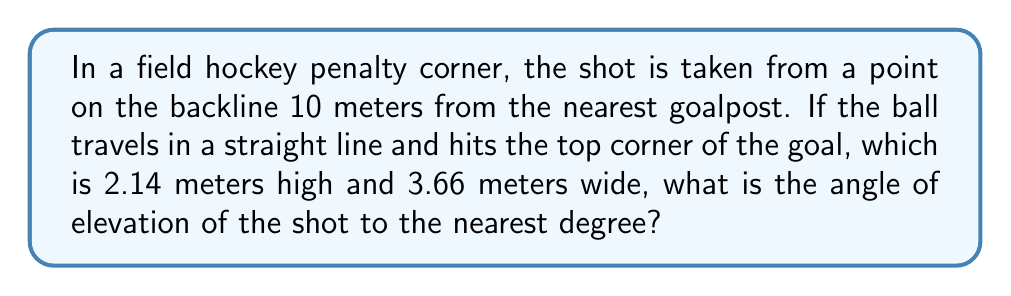Could you help me with this problem? To solve this problem, we need to use trigonometry. Let's break it down step-by-step:

1. Visualize the scenario:
   [asy]
   unitsize(1cm);
   pair A = (0,0), B = (10,0), C = (13.66,2.14);
   draw(A--B--C--A);
   label("A", A, SW);
   label("B", B, SE);
   label("C", C, NE);
   label("10m", (A+B)/2, S);
   label("3.66m", (B+C)/2, NE);
   label("2.14m", C, W);
   label("θ", B, NW);
   [/asy]

2. We have a right-angled triangle ABC, where:
   - AB is the distance along the backline (10m)
   - BC is the width of the goal (3.66m)
   - AC is the path of the ball
   - The height of point C is 2.14m

3. To find the angle of elevation (θ), we need to use the arctangent function:

   $$\theta = \arctan(\frac{\text{opposite}}{\text{adjacent}})$$

4. The opposite side is the height of the goal (2.14m)
   The adjacent side is the hypotenuse of the triangle formed on the ground:

   $$\text{adjacent} = \sqrt{10^2 + 3.66^2} = \sqrt{100 + 13.3956} = \sqrt{113.3956} \approx 10.65m$$

5. Now we can calculate the angle:

   $$\theta = \arctan(\frac{2.14}{10.65}) \approx 0.1989 \text{ radians}$$

6. Convert radians to degrees:

   $$\theta = 0.1989 \times \frac{180^{\circ}}{\pi} \approx 11.40^{\circ}$$

7. Rounding to the nearest degree:

   $$\theta \approx 11^{\circ}$$
Answer: $11^{\circ}$ 